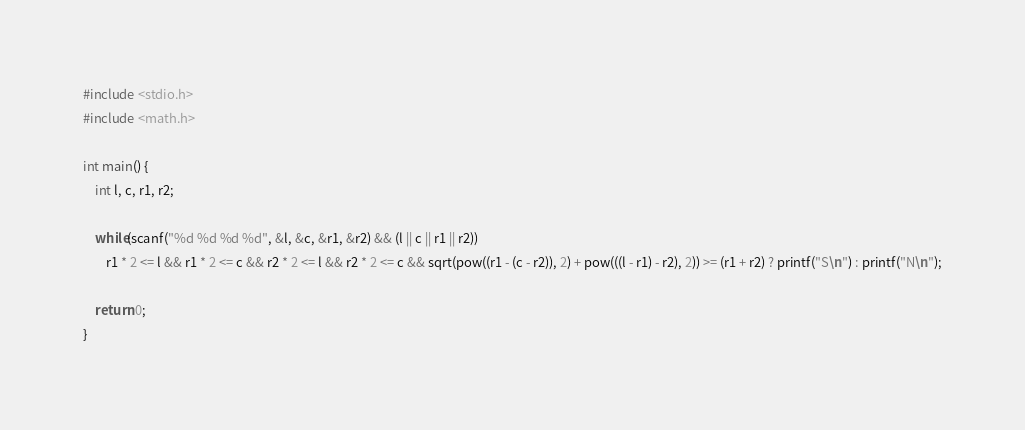Convert code to text. <code><loc_0><loc_0><loc_500><loc_500><_C_>#include <stdio.h>
#include <math.h>

int main() {
    int l, c, r1, r2;

    while(scanf("%d %d %d %d", &l, &c, &r1, &r2) && (l || c || r1 || r2))
        r1 * 2 <= l && r1 * 2 <= c && r2 * 2 <= l && r2 * 2 <= c && sqrt(pow((r1 - (c - r2)), 2) + pow(((l - r1) - r2), 2)) >= (r1 + r2) ? printf("S\n") : printf("N\n");

    return 0;
}</code> 